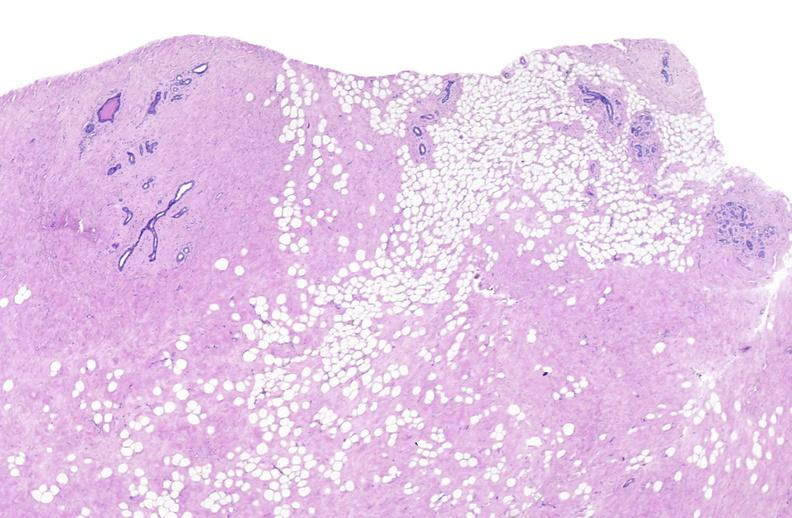does all the fat necrosis show breast, fibroadenoma?
Answer the question using a single word or phrase. No 